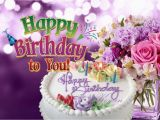Can you describe the cake shown in the image? The cake in the image is a circular, white-frosted cake with multiple vibrantly colored candles protruding from the top. The decorative frosting is artistically applied, and pastel-hued icing spells out 'Happy Birthday' in a flowing, cursive font. The cake exudes a joyful, celebratory aura suitable for a birthday occasion. 